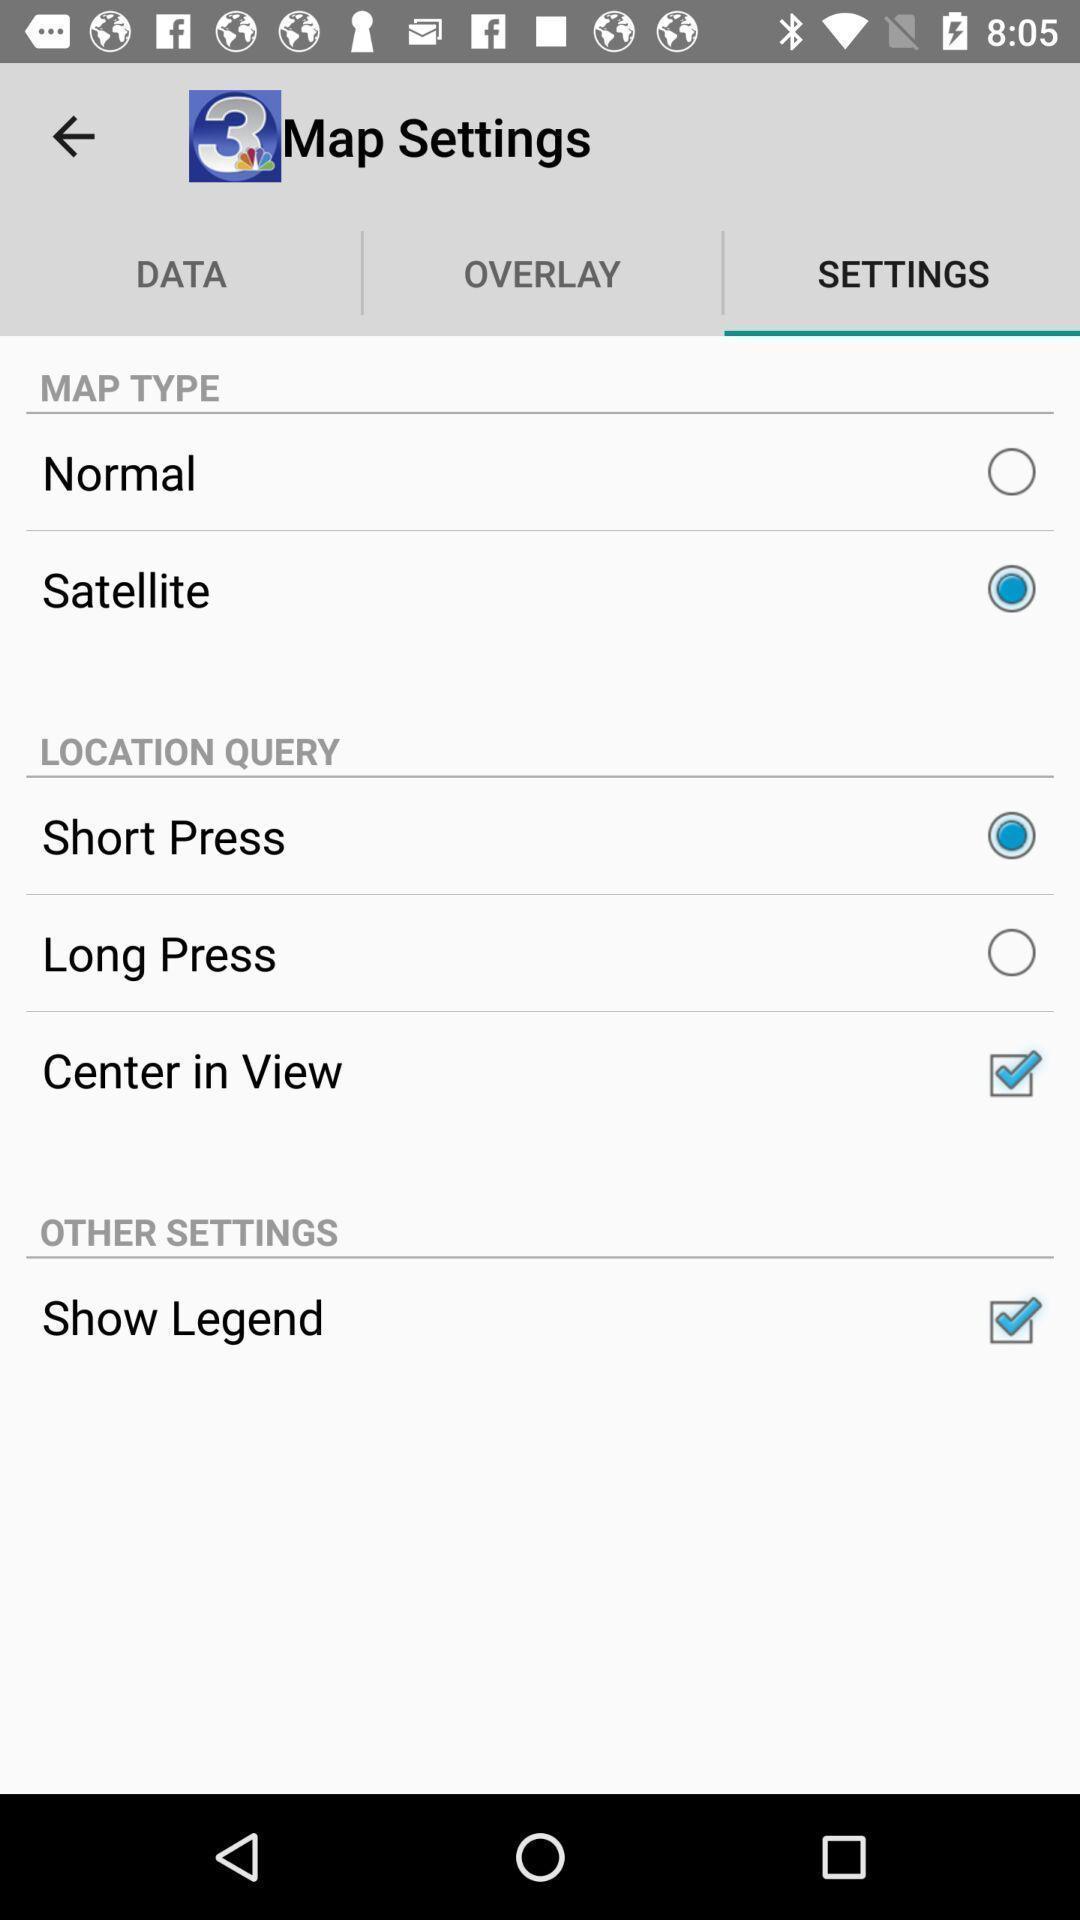Describe this image in words. Screen showing all the settings. 